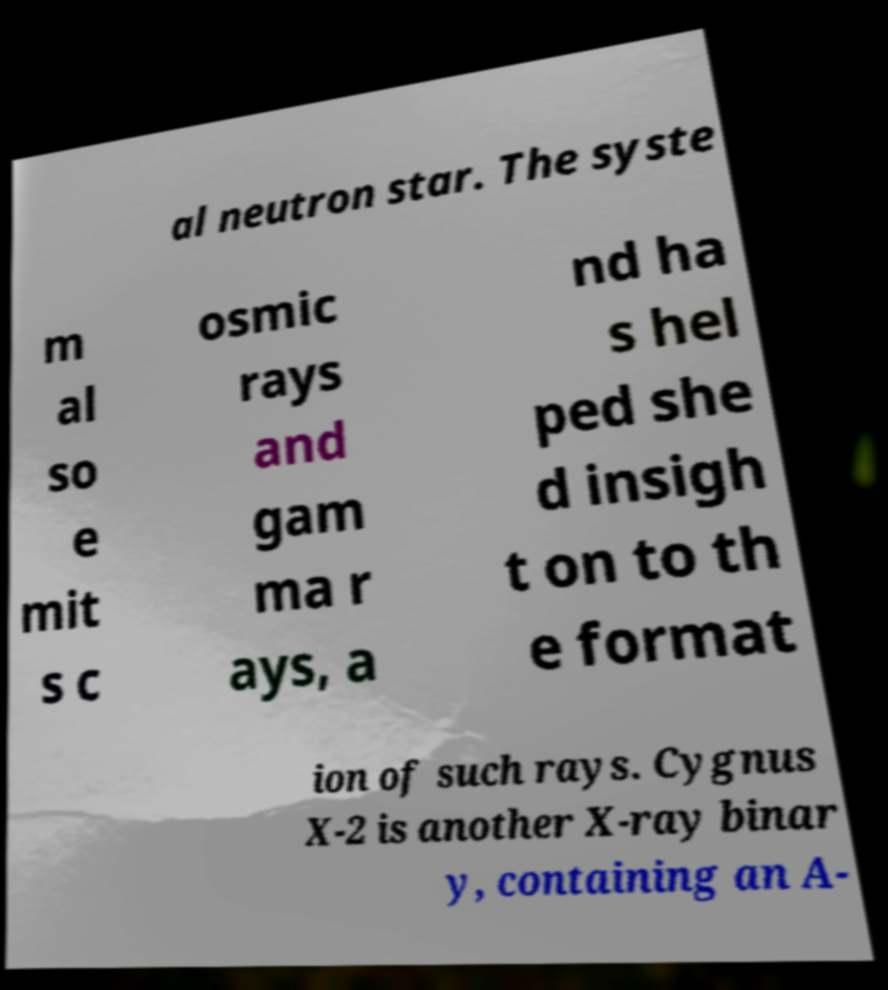Can you accurately transcribe the text from the provided image for me? al neutron star. The syste m al so e mit s c osmic rays and gam ma r ays, a nd ha s hel ped she d insigh t on to th e format ion of such rays. Cygnus X-2 is another X-ray binar y, containing an A- 